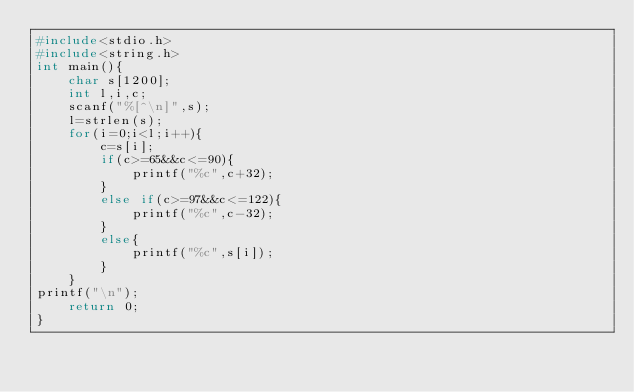Convert code to text. <code><loc_0><loc_0><loc_500><loc_500><_C++_>#include<stdio.h>
#include<string.h>
int main(){
    char s[1200];
    int l,i,c;
    scanf("%[^\n]",s);
    l=strlen(s);
    for(i=0;i<l;i++){
        c=s[i];
        if(c>=65&&c<=90){
            printf("%c",c+32);
        }
        else if(c>=97&&c<=122){
            printf("%c",c-32);
        }
        else{
            printf("%c",s[i]);
        }
    }
printf("\n");
    return 0;
}

</code> 